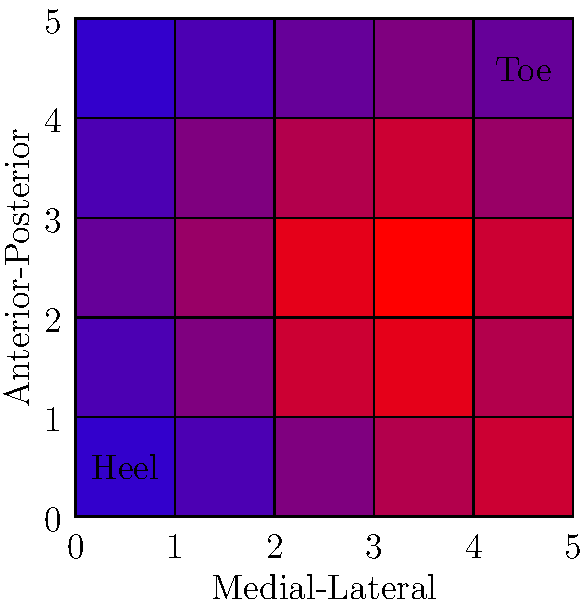Based on the heat map graphic of force distribution in a sprinter's foot strike, which area of the foot experiences the highest force during the sprint, and what might this suggest about the sprinter's technique? To analyze the force distribution in a sprinter's foot strike:

1. Observe the color gradient: Blue represents lower force, while red represents higher force.

2. Identify the area with the most intense red color: This is located in the anterior (front) and slightly lateral (outer) part of the foot.

3. Relate this to foot anatomy: The area of highest force corresponds to the ball of the foot, specifically under the first and second metatarsal heads.

4. Consider sprinting technique:
   a) Sprinters typically land on the ball of their foot to maximize speed and efficiency.
   b) This technique allows for quick push-off and reduces ground contact time.

5. Analyze force distribution pattern:
   a) The heel shows minimal force, indicating little to no heel strike.
   b) Force increases towards the front of the foot, peaking at the ball.
   c) There's a slight lateral bias, suggesting the sprinter may pronate slightly during push-off.

6. Implications for technique:
   a) The concentrated force on the ball of the foot is consistent with proper sprinting form.
   b) The slight lateral bias might indicate a need for minor technique adjustment or could be within normal variation.

7. Biomechanical efficiency:
   a) This force distribution allows for optimal energy transfer and explosive push-off.
   b) It minimizes braking forces that would occur with a heel strike.

In conclusion, the heat map suggests the sprinter is using proper technique by landing on the ball of the foot, which allows for maximum speed and efficiency in force transfer during the sprint.
Answer: Ball of the foot; indicates proper sprinting technique with forefoot strike for optimal speed and efficiency. 